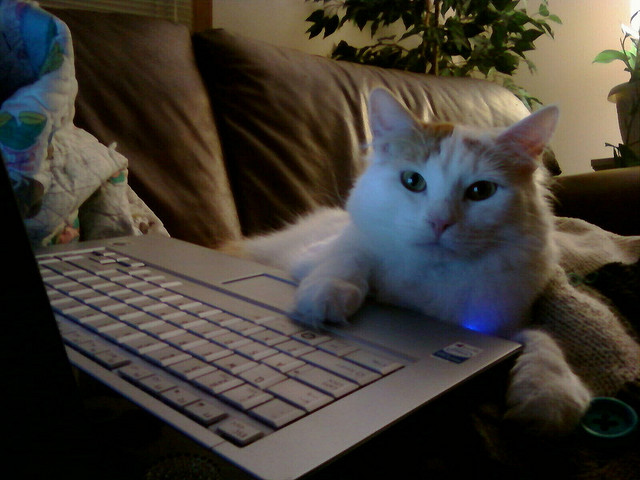<image>What is the cat typing? The cat is not typing anything. It is also impossible to clarify what it is typing. What is the cat typing? I don't know what the cat is typing. It could be anything. 